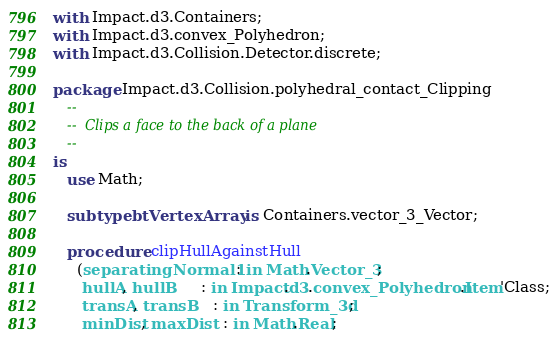<code> <loc_0><loc_0><loc_500><loc_500><_Ada_>with Impact.d3.Containers;
with Impact.d3.convex_Polyhedron;
with Impact.d3.Collision.Detector.discrete;

package Impact.d3.Collision.polyhedral_contact_Clipping
   --
   --  Clips a face to the back of a plane
   --
is
   use Math;

   subtype btVertexArray is Containers.vector_3_Vector;

   procedure clipHullAgainstHull
     (separatingNormal1 : in Math.Vector_3;
      hullA, hullB      : in Impact.d3.convex_Polyhedron.Item'Class;
      transA, transB    : in Transform_3d;
      minDist, maxDist  : in Math.Real;</code> 